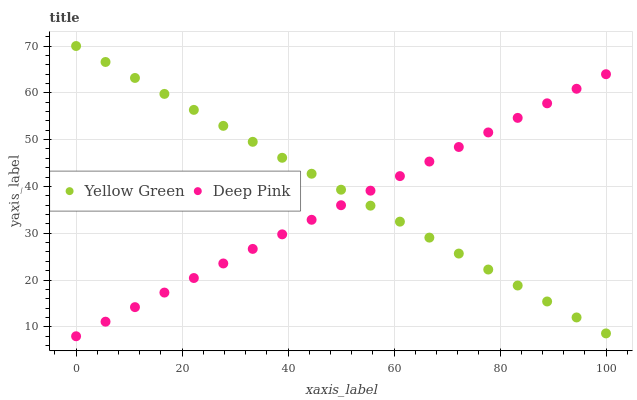Does Deep Pink have the minimum area under the curve?
Answer yes or no. Yes. Does Yellow Green have the maximum area under the curve?
Answer yes or no. Yes. Does Yellow Green have the minimum area under the curve?
Answer yes or no. No. Is Deep Pink the smoothest?
Answer yes or no. Yes. Is Yellow Green the roughest?
Answer yes or no. Yes. Is Yellow Green the smoothest?
Answer yes or no. No. Does Deep Pink have the lowest value?
Answer yes or no. Yes. Does Yellow Green have the lowest value?
Answer yes or no. No. Does Yellow Green have the highest value?
Answer yes or no. Yes. Does Deep Pink intersect Yellow Green?
Answer yes or no. Yes. Is Deep Pink less than Yellow Green?
Answer yes or no. No. Is Deep Pink greater than Yellow Green?
Answer yes or no. No. 